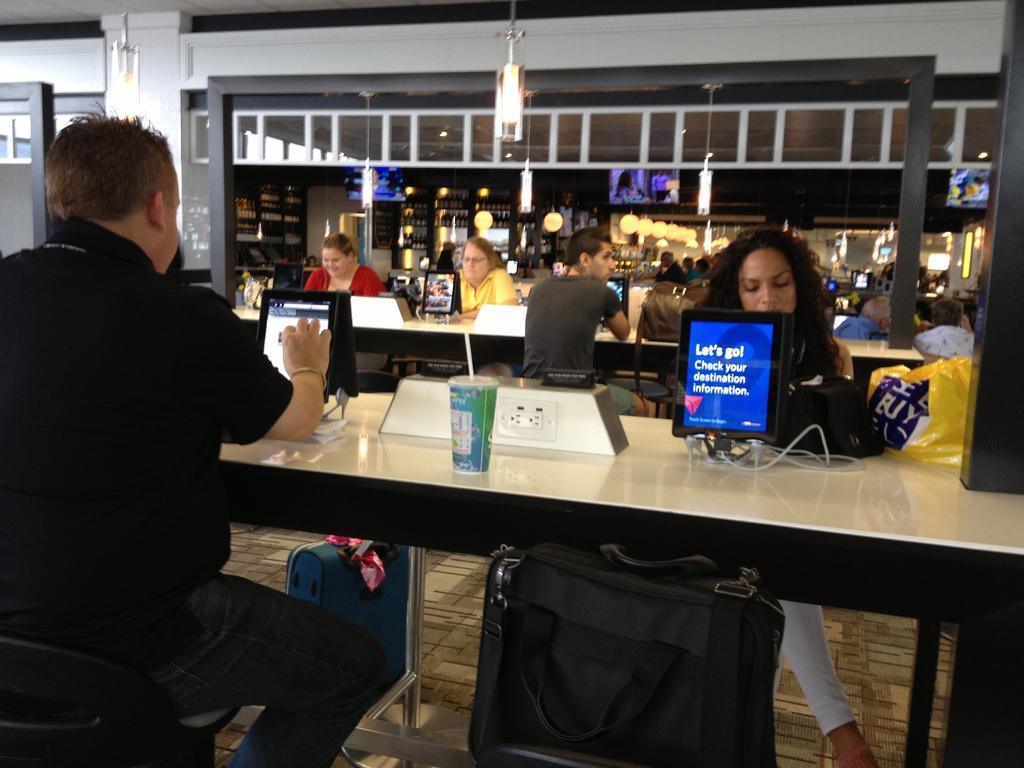Can you describe this image briefly? This picture describes about group of people few are seated on the chair and few are standing in front of the seated people we can find tablets, sockets, cups and bags on the table, in the background we can find couple of lights. 